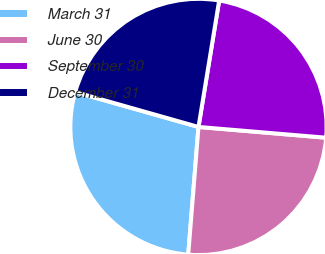Convert chart. <chart><loc_0><loc_0><loc_500><loc_500><pie_chart><fcel>March 31<fcel>June 30<fcel>September 30<fcel>December 31<nl><fcel>28.12%<fcel>24.94%<fcel>23.76%<fcel>23.19%<nl></chart> 